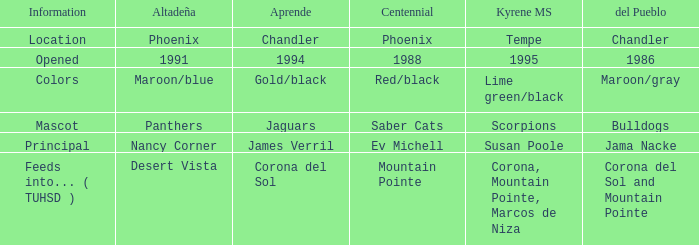Which Altadeña has a Aprende of jaguars? Panthers. 